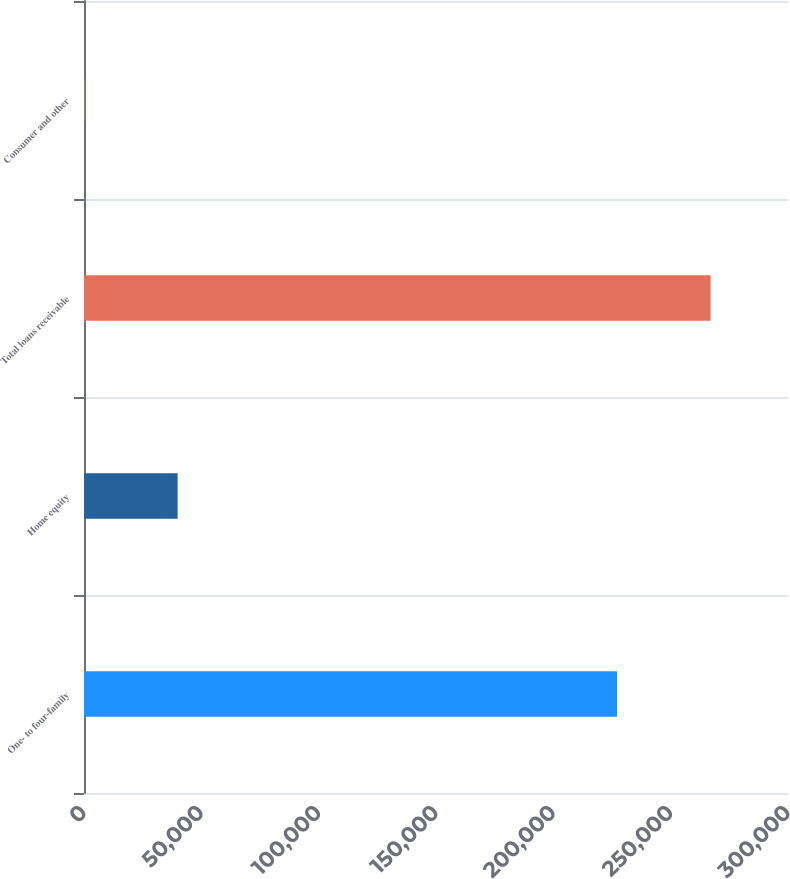Convert chart. <chart><loc_0><loc_0><loc_500><loc_500><bar_chart><fcel>One- to four-family<fcel>Home equity<fcel>Total loans receivable<fcel>Consumer and other<nl><fcel>227115<fcel>39904<fcel>267019<fcel>195<nl></chart> 